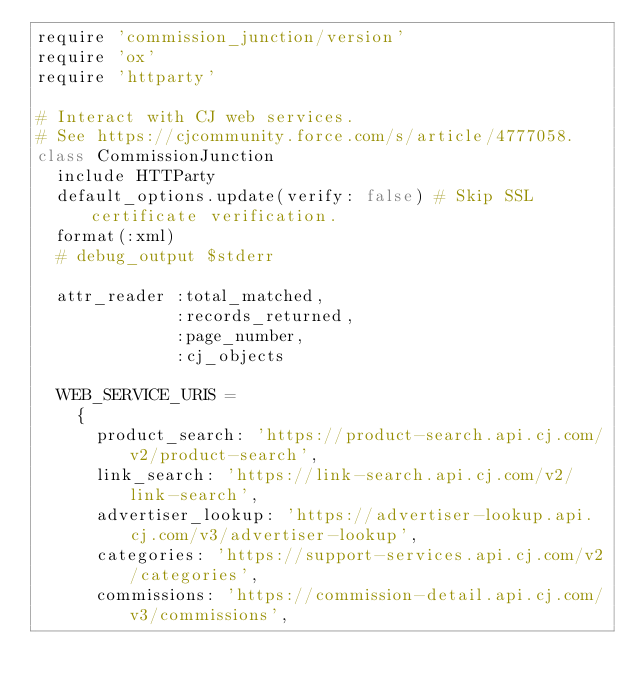Convert code to text. <code><loc_0><loc_0><loc_500><loc_500><_Ruby_>require 'commission_junction/version'
require 'ox'
require 'httparty'

# Interact with CJ web services.
# See https://cjcommunity.force.com/s/article/4777058.
class CommissionJunction
  include HTTParty
  default_options.update(verify: false) # Skip SSL certificate verification.
  format(:xml)
  # debug_output $stderr

  attr_reader :total_matched,
              :records_returned,
              :page_number,
              :cj_objects

  WEB_SERVICE_URIS =
    {
      product_search: 'https://product-search.api.cj.com/v2/product-search',
      link_search: 'https://link-search.api.cj.com/v2/link-search',
      advertiser_lookup: 'https://advertiser-lookup.api.cj.com/v3/advertiser-lookup',
      categories: 'https://support-services.api.cj.com/v2/categories',
      commissions: 'https://commission-detail.api.cj.com/v3/commissions',</code> 